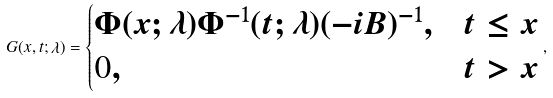<formula> <loc_0><loc_0><loc_500><loc_500>G ( x , t ; \lambda ) = \begin{cases} \Phi ( x ; \lambda ) \Phi ^ { - 1 } ( t ; \lambda ) ( - i B ) ^ { - 1 } , & t \leq x \\ 0 , & t > x \end{cases} ,</formula> 